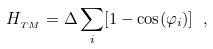Convert formula to latex. <formula><loc_0><loc_0><loc_500><loc_500>H _ { _ { T M } } = \Delta \sum _ { i } [ 1 - \cos ( \varphi _ { i } ) ] \ ,</formula> 